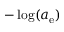<formula> <loc_0><loc_0><loc_500><loc_500>- \log ( a _ { e } )</formula> 